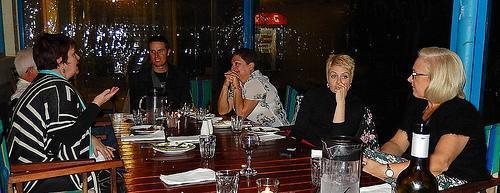How many people are there?
Give a very brief answer. 6. 